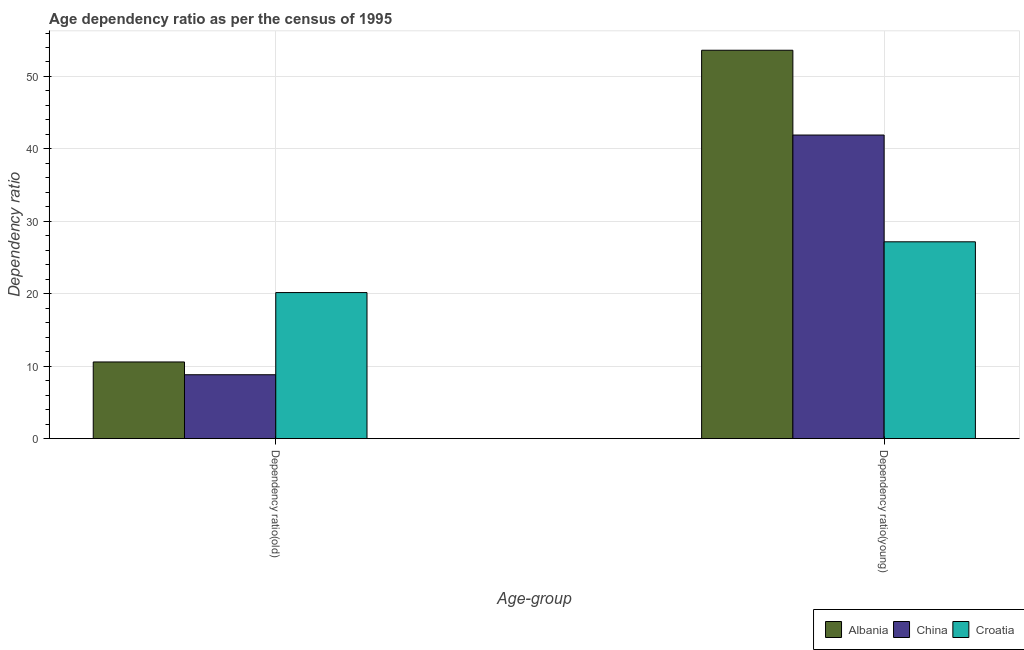How many different coloured bars are there?
Provide a short and direct response. 3. How many groups of bars are there?
Ensure brevity in your answer.  2. Are the number of bars per tick equal to the number of legend labels?
Make the answer very short. Yes. How many bars are there on the 1st tick from the right?
Provide a succinct answer. 3. What is the label of the 2nd group of bars from the left?
Offer a terse response. Dependency ratio(young). What is the age dependency ratio(young) in China?
Offer a terse response. 41.91. Across all countries, what is the maximum age dependency ratio(young)?
Offer a very short reply. 53.62. Across all countries, what is the minimum age dependency ratio(old)?
Provide a succinct answer. 8.82. In which country was the age dependency ratio(young) maximum?
Give a very brief answer. Albania. In which country was the age dependency ratio(young) minimum?
Offer a terse response. Croatia. What is the total age dependency ratio(young) in the graph?
Offer a terse response. 122.71. What is the difference between the age dependency ratio(young) in China and that in Croatia?
Offer a very short reply. 14.74. What is the difference between the age dependency ratio(old) in Albania and the age dependency ratio(young) in Croatia?
Ensure brevity in your answer.  -16.59. What is the average age dependency ratio(young) per country?
Provide a short and direct response. 40.9. What is the difference between the age dependency ratio(old) and age dependency ratio(young) in Croatia?
Offer a very short reply. -7.01. In how many countries, is the age dependency ratio(young) greater than 44 ?
Provide a succinct answer. 1. What is the ratio of the age dependency ratio(old) in Croatia to that in Albania?
Offer a terse response. 1.91. Is the age dependency ratio(young) in Croatia less than that in China?
Offer a very short reply. Yes. In how many countries, is the age dependency ratio(young) greater than the average age dependency ratio(young) taken over all countries?
Make the answer very short. 2. What does the 1st bar from the left in Dependency ratio(young) represents?
Offer a terse response. Albania. What does the 1st bar from the right in Dependency ratio(young) represents?
Provide a succinct answer. Croatia. How many countries are there in the graph?
Keep it short and to the point. 3. Are the values on the major ticks of Y-axis written in scientific E-notation?
Offer a terse response. No. Where does the legend appear in the graph?
Offer a terse response. Bottom right. How many legend labels are there?
Your response must be concise. 3. What is the title of the graph?
Your answer should be compact. Age dependency ratio as per the census of 1995. Does "Niger" appear as one of the legend labels in the graph?
Provide a succinct answer. No. What is the label or title of the X-axis?
Ensure brevity in your answer.  Age-group. What is the label or title of the Y-axis?
Give a very brief answer. Dependency ratio. What is the Dependency ratio of Albania in Dependency ratio(old)?
Your answer should be very brief. 10.58. What is the Dependency ratio of China in Dependency ratio(old)?
Your response must be concise. 8.82. What is the Dependency ratio in Croatia in Dependency ratio(old)?
Your answer should be compact. 20.16. What is the Dependency ratio of Albania in Dependency ratio(young)?
Your response must be concise. 53.62. What is the Dependency ratio in China in Dependency ratio(young)?
Give a very brief answer. 41.91. What is the Dependency ratio in Croatia in Dependency ratio(young)?
Give a very brief answer. 27.17. Across all Age-group, what is the maximum Dependency ratio in Albania?
Provide a short and direct response. 53.62. Across all Age-group, what is the maximum Dependency ratio of China?
Provide a succinct answer. 41.91. Across all Age-group, what is the maximum Dependency ratio of Croatia?
Keep it short and to the point. 27.17. Across all Age-group, what is the minimum Dependency ratio of Albania?
Keep it short and to the point. 10.58. Across all Age-group, what is the minimum Dependency ratio of China?
Offer a very short reply. 8.82. Across all Age-group, what is the minimum Dependency ratio of Croatia?
Provide a short and direct response. 20.16. What is the total Dependency ratio of Albania in the graph?
Make the answer very short. 64.2. What is the total Dependency ratio of China in the graph?
Keep it short and to the point. 50.73. What is the total Dependency ratio of Croatia in the graph?
Give a very brief answer. 47.34. What is the difference between the Dependency ratio of Albania in Dependency ratio(old) and that in Dependency ratio(young)?
Keep it short and to the point. -43.04. What is the difference between the Dependency ratio of China in Dependency ratio(old) and that in Dependency ratio(young)?
Your answer should be compact. -33.09. What is the difference between the Dependency ratio of Croatia in Dependency ratio(old) and that in Dependency ratio(young)?
Provide a succinct answer. -7.01. What is the difference between the Dependency ratio in Albania in Dependency ratio(old) and the Dependency ratio in China in Dependency ratio(young)?
Your response must be concise. -31.33. What is the difference between the Dependency ratio in Albania in Dependency ratio(old) and the Dependency ratio in Croatia in Dependency ratio(young)?
Give a very brief answer. -16.59. What is the difference between the Dependency ratio of China in Dependency ratio(old) and the Dependency ratio of Croatia in Dependency ratio(young)?
Keep it short and to the point. -18.35. What is the average Dependency ratio of Albania per Age-group?
Offer a very short reply. 32.1. What is the average Dependency ratio in China per Age-group?
Keep it short and to the point. 25.37. What is the average Dependency ratio in Croatia per Age-group?
Your answer should be very brief. 23.67. What is the difference between the Dependency ratio in Albania and Dependency ratio in China in Dependency ratio(old)?
Give a very brief answer. 1.76. What is the difference between the Dependency ratio of Albania and Dependency ratio of Croatia in Dependency ratio(old)?
Ensure brevity in your answer.  -9.58. What is the difference between the Dependency ratio in China and Dependency ratio in Croatia in Dependency ratio(old)?
Offer a terse response. -11.34. What is the difference between the Dependency ratio of Albania and Dependency ratio of China in Dependency ratio(young)?
Keep it short and to the point. 11.71. What is the difference between the Dependency ratio of Albania and Dependency ratio of Croatia in Dependency ratio(young)?
Keep it short and to the point. 26.45. What is the difference between the Dependency ratio in China and Dependency ratio in Croatia in Dependency ratio(young)?
Provide a succinct answer. 14.74. What is the ratio of the Dependency ratio of Albania in Dependency ratio(old) to that in Dependency ratio(young)?
Your answer should be compact. 0.2. What is the ratio of the Dependency ratio in China in Dependency ratio(old) to that in Dependency ratio(young)?
Make the answer very short. 0.21. What is the ratio of the Dependency ratio of Croatia in Dependency ratio(old) to that in Dependency ratio(young)?
Keep it short and to the point. 0.74. What is the difference between the highest and the second highest Dependency ratio of Albania?
Give a very brief answer. 43.04. What is the difference between the highest and the second highest Dependency ratio in China?
Offer a terse response. 33.09. What is the difference between the highest and the second highest Dependency ratio in Croatia?
Ensure brevity in your answer.  7.01. What is the difference between the highest and the lowest Dependency ratio of Albania?
Provide a succinct answer. 43.04. What is the difference between the highest and the lowest Dependency ratio of China?
Provide a succinct answer. 33.09. What is the difference between the highest and the lowest Dependency ratio in Croatia?
Your response must be concise. 7.01. 